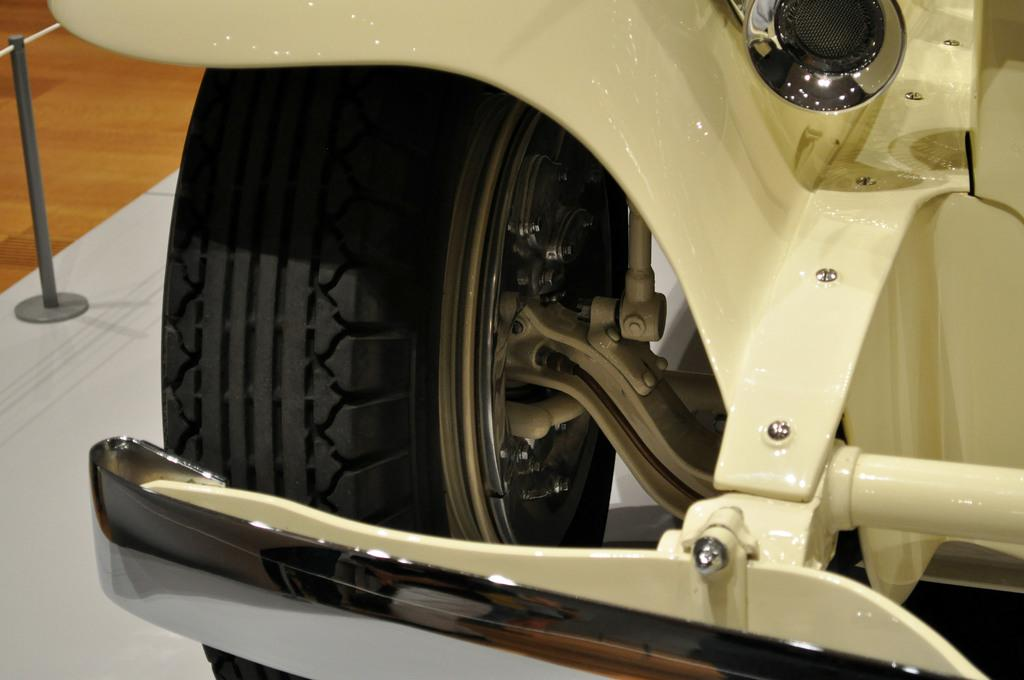What type of vehicle is in the image? There is a Koenigsegg CCX in the image. What committee is responsible for the expansion of the Koenigsegg CCX in the image? There is no committee or expansion mentioned in the image; it simply features a Koenigsegg CCX. 